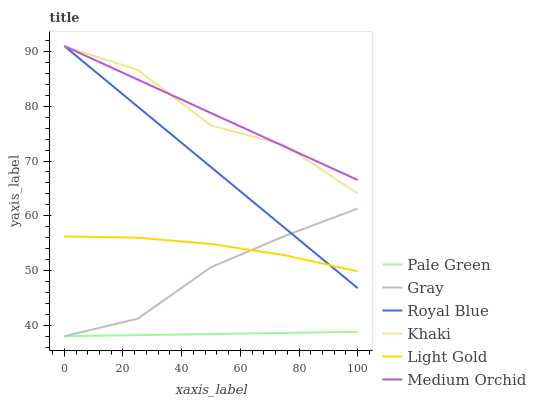Does Pale Green have the minimum area under the curve?
Answer yes or no. Yes. Does Medium Orchid have the maximum area under the curve?
Answer yes or no. Yes. Does Khaki have the minimum area under the curve?
Answer yes or no. No. Does Khaki have the maximum area under the curve?
Answer yes or no. No. Is Royal Blue the smoothest?
Answer yes or no. Yes. Is Khaki the roughest?
Answer yes or no. Yes. Is Medium Orchid the smoothest?
Answer yes or no. No. Is Medium Orchid the roughest?
Answer yes or no. No. Does Gray have the lowest value?
Answer yes or no. Yes. Does Khaki have the lowest value?
Answer yes or no. No. Does Royal Blue have the highest value?
Answer yes or no. Yes. Does Khaki have the highest value?
Answer yes or no. No. Is Pale Green less than Khaki?
Answer yes or no. Yes. Is Khaki greater than Gray?
Answer yes or no. Yes. Does Pale Green intersect Gray?
Answer yes or no. Yes. Is Pale Green less than Gray?
Answer yes or no. No. Is Pale Green greater than Gray?
Answer yes or no. No. Does Pale Green intersect Khaki?
Answer yes or no. No. 